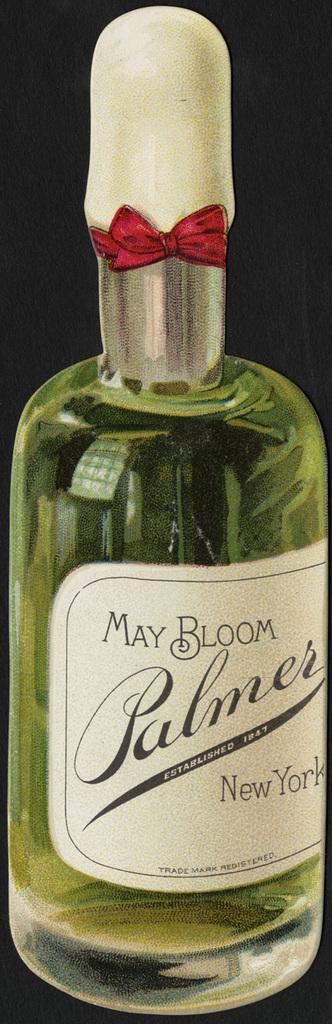Provide a one-sentence caption for the provided image. a new bottle of may bloom plamer new york. 